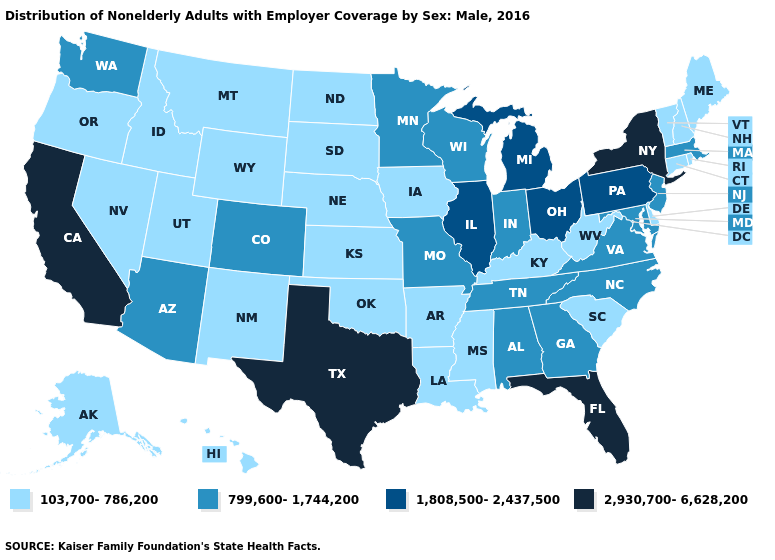What is the value of Connecticut?
Keep it brief. 103,700-786,200. Among the states that border New Jersey , which have the highest value?
Be succinct. New York. Is the legend a continuous bar?
Quick response, please. No. What is the value of South Dakota?
Give a very brief answer. 103,700-786,200. What is the lowest value in the USA?
Answer briefly. 103,700-786,200. Does Missouri have the lowest value in the USA?
Quick response, please. No. What is the highest value in the USA?
Quick response, please. 2,930,700-6,628,200. Is the legend a continuous bar?
Keep it brief. No. What is the value of New Jersey?
Be succinct. 799,600-1,744,200. Name the states that have a value in the range 799,600-1,744,200?
Short answer required. Alabama, Arizona, Colorado, Georgia, Indiana, Maryland, Massachusetts, Minnesota, Missouri, New Jersey, North Carolina, Tennessee, Virginia, Washington, Wisconsin. What is the highest value in the South ?
Concise answer only. 2,930,700-6,628,200. Among the states that border Vermont , which have the lowest value?
Answer briefly. New Hampshire. Which states have the lowest value in the West?
Be succinct. Alaska, Hawaii, Idaho, Montana, Nevada, New Mexico, Oregon, Utah, Wyoming. 